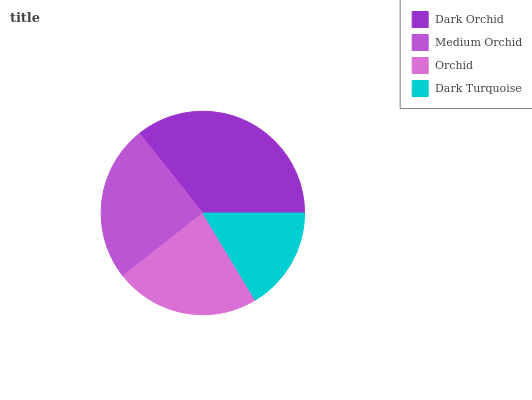Is Dark Turquoise the minimum?
Answer yes or no. Yes. Is Dark Orchid the maximum?
Answer yes or no. Yes. Is Medium Orchid the minimum?
Answer yes or no. No. Is Medium Orchid the maximum?
Answer yes or no. No. Is Dark Orchid greater than Medium Orchid?
Answer yes or no. Yes. Is Medium Orchid less than Dark Orchid?
Answer yes or no. Yes. Is Medium Orchid greater than Dark Orchid?
Answer yes or no. No. Is Dark Orchid less than Medium Orchid?
Answer yes or no. No. Is Medium Orchid the high median?
Answer yes or no. Yes. Is Orchid the low median?
Answer yes or no. Yes. Is Orchid the high median?
Answer yes or no. No. Is Medium Orchid the low median?
Answer yes or no. No. 